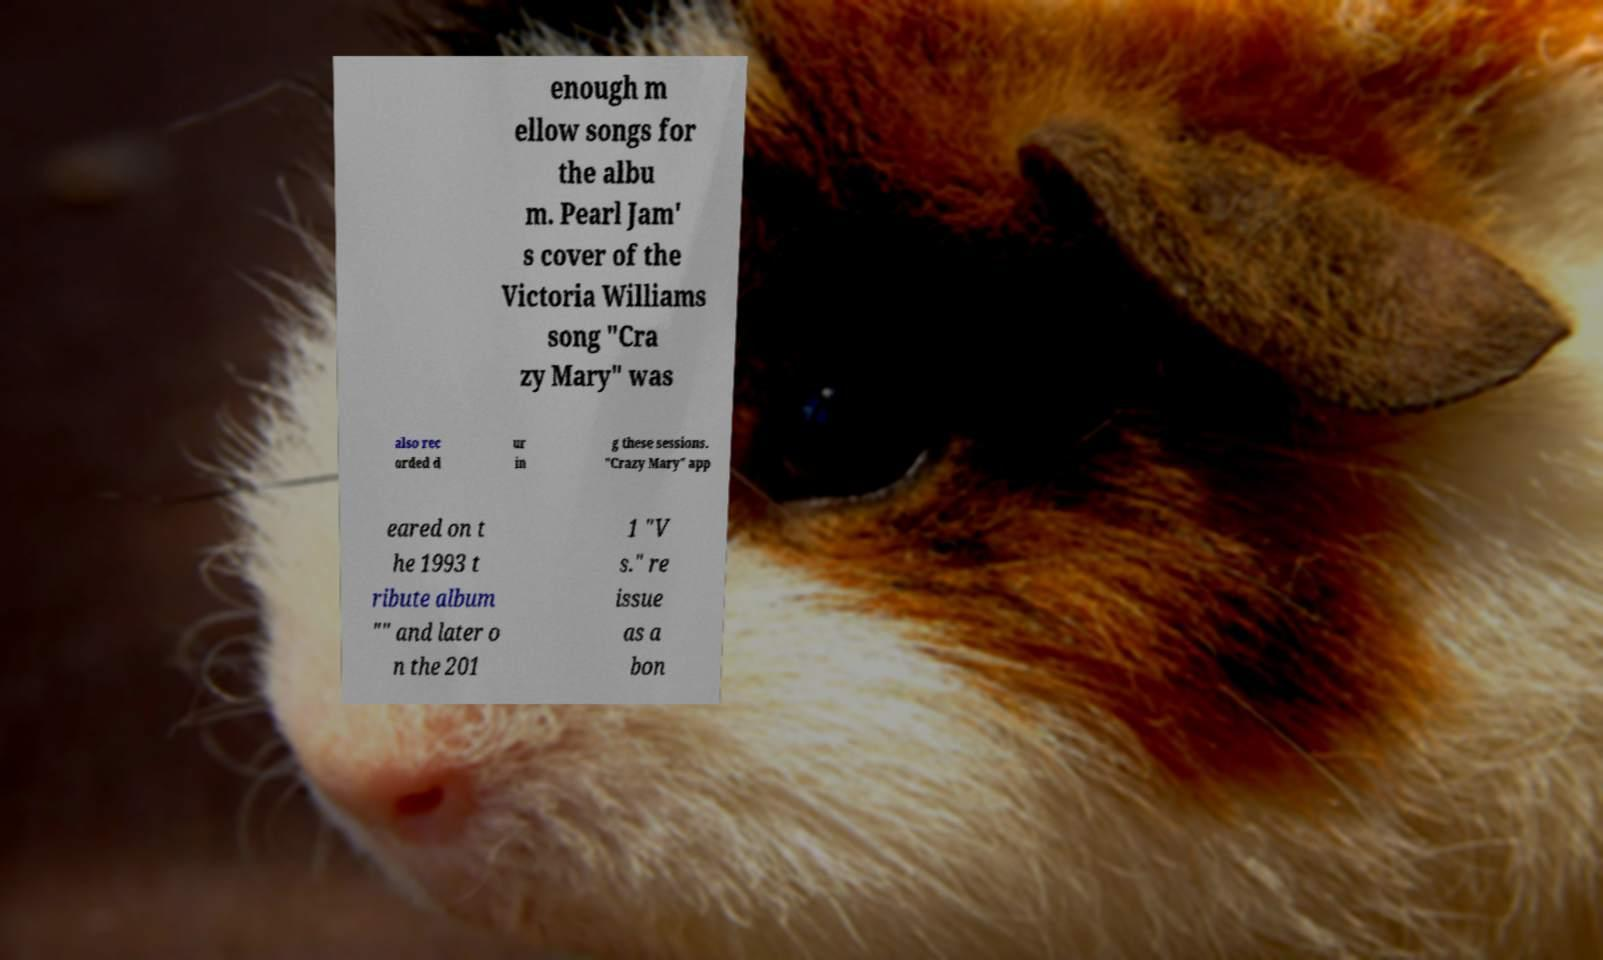Could you extract and type out the text from this image? enough m ellow songs for the albu m. Pearl Jam' s cover of the Victoria Williams song "Cra zy Mary" was also rec orded d ur in g these sessions. "Crazy Mary" app eared on t he 1993 t ribute album "" and later o n the 201 1 "V s." re issue as a bon 